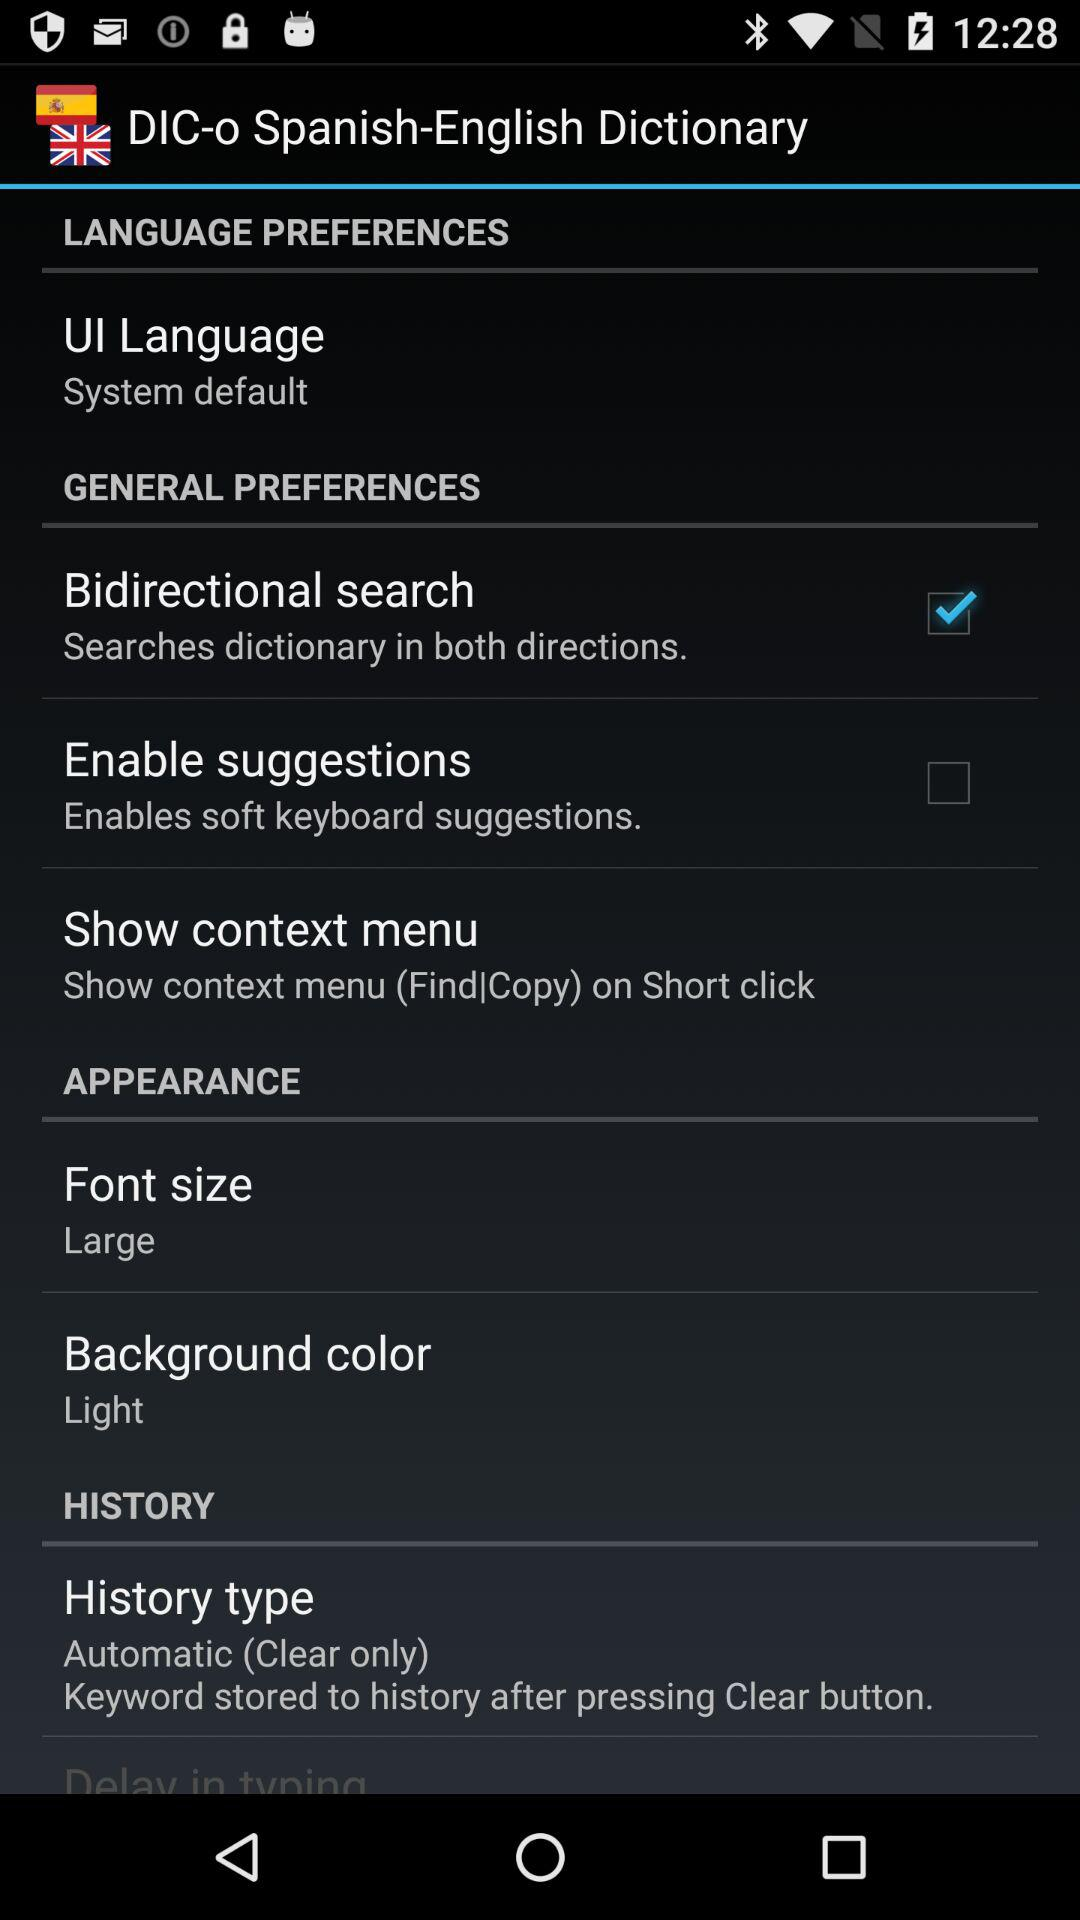What is the size of the font? The size of the font is large. 